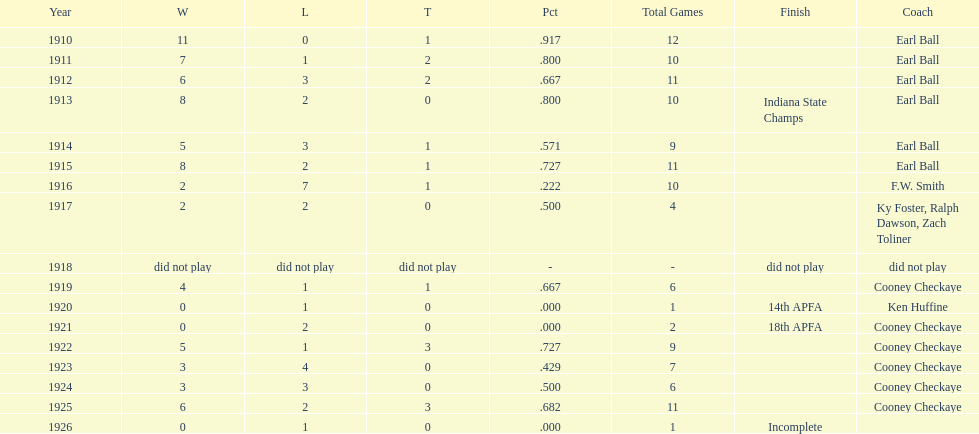How many years did cooney checkaye coach the muncie flyers? 6. 